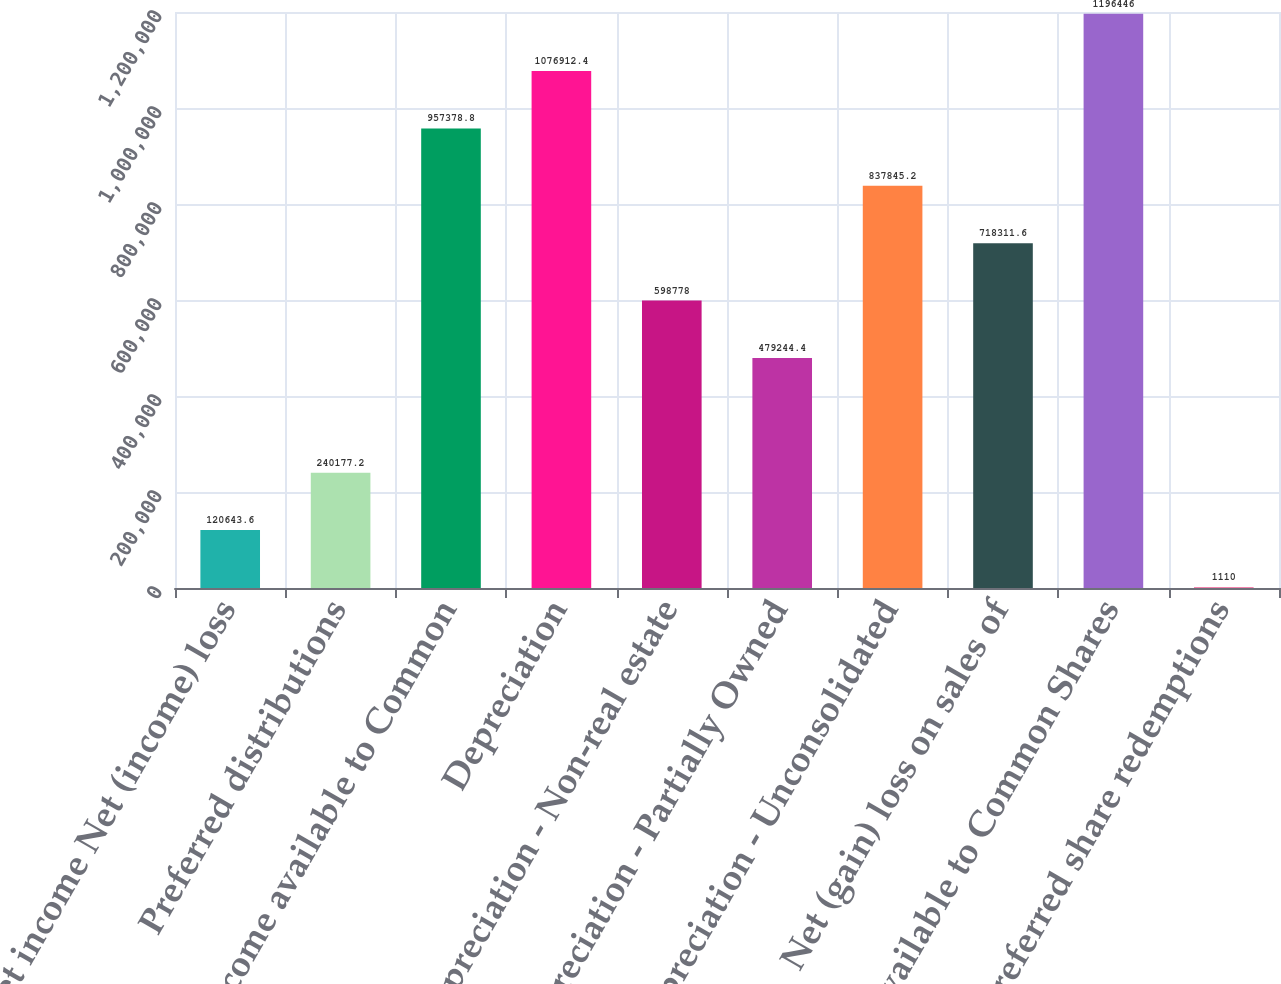Convert chart to OTSL. <chart><loc_0><loc_0><loc_500><loc_500><bar_chart><fcel>Net income Net (income) loss<fcel>Preferred distributions<fcel>Net income available to Common<fcel>Depreciation<fcel>Depreciation - Non-real estate<fcel>Depreciation - Partially Owned<fcel>Depreciation - Unconsolidated<fcel>Net (gain) loss on sales of<fcel>FFO available to Common Shares<fcel>preferred share redemptions<nl><fcel>120644<fcel>240177<fcel>957379<fcel>1.07691e+06<fcel>598778<fcel>479244<fcel>837845<fcel>718312<fcel>1.19645e+06<fcel>1110<nl></chart> 